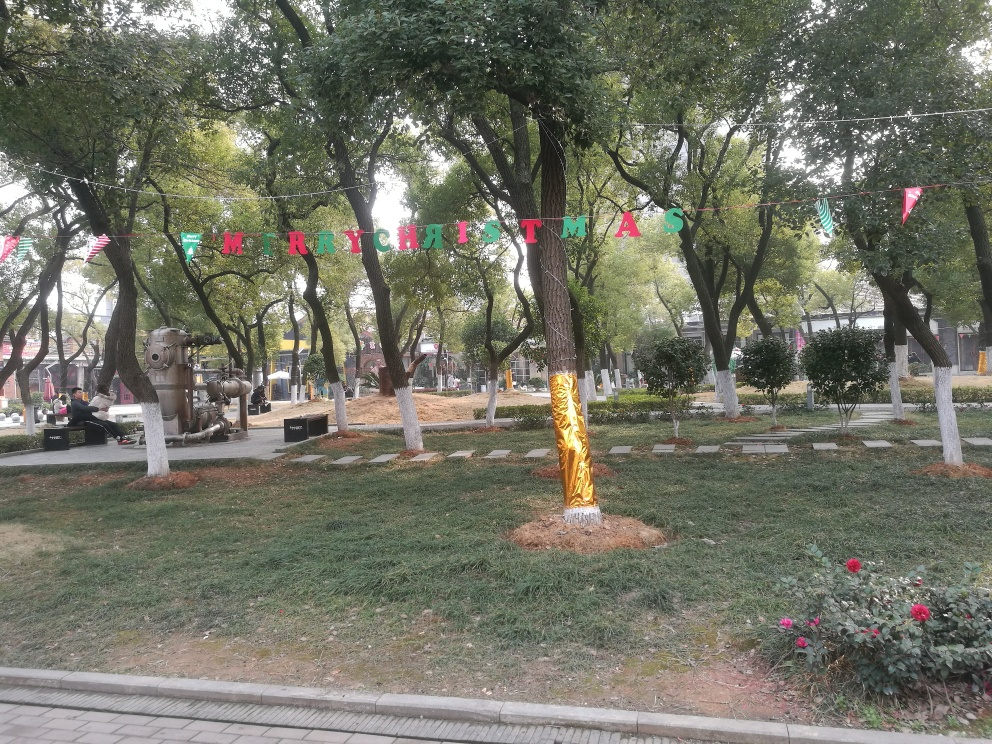What is the subject of the image?
A. The subject is a river.
B. The subject is trees and a lawn.
C. The subject is a cityscape. The primary subjects of the image are trees and a lawn, which are option B. The image features a lush green space with scattered trees, some benches, and a tidy arrangement of walking paths. It appears to be an urban park decorated for Christmas, as seen by the 'MERRY CHRISTMAS' banner strung between the trees. 